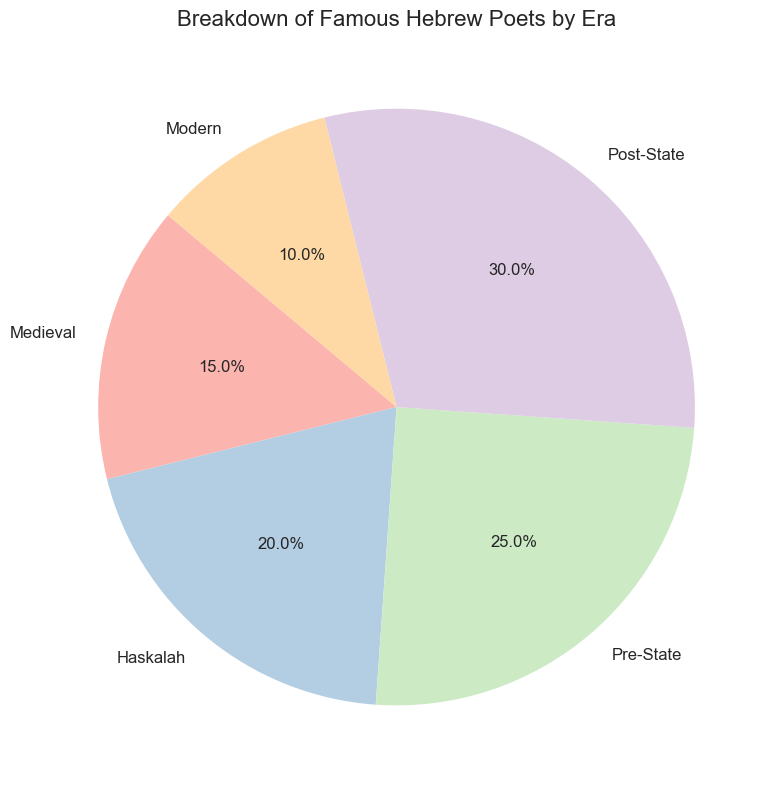What era has the largest representation of famous Hebrew poets according to the chart? Look at the wedges of the pie chart, the era with the largest wedge will have the largest representation. The "Post-State" era has the largest wedge with 30%.
Answer: Post-State What percentage of famous Hebrew poets belongs to the Medieval and Haskalah eras combined? Check the percentages for the Medieval and Haskalah eras, and add them together. Medieval is 15% and Haskalah is 20%, so 15% + 20% = 35%.
Answer: 35% Which era has a smaller representation of famous Hebrew poets, Medieval or Modern? Compare the sizes of the wedges labeled Medieval and Modern. Medieval is 15% and Modern is 10%, thus Modern is smaller.
Answer: Modern By what percentage is the representation of famous Hebrew poets in the Pre-State era greater than the Medieval era? Subtract the percentage of the Medieval era from the Pre-State era. Pre-State is 25% and Medieval is 15%, so 25% - 15% = 10%.
Answer: 10% Rank the eras from highest to lowest percentage of famous Hebrew poets. Order the eras according to their given percentages. Post-State (30%), Pre-State (25%), Haskalah (20%), Medieval (15%), Modern (10%).
Answer: Post-State, Pre-State, Haskalah, Medieval, Modern What fraction of the pie does the Post-State era occupy? Convert the percentage of the Post-State era to a fraction. Post-State is 30%, which is 30/100 or 3/10.
Answer: 3/10 Are the Medieval and Modern eras combined less than the Haskalah era? Add the percentages of the Medieval and Modern eras and compare with the Haskalah era. Medieval is 15% and Modern is 10%, so combined they are 25%, which is the same as Haskalah at 20%.
Answer: No How does the representation of famous Hebrew poets in the Modern era compare to the combined percentage of the Medieval and Pre-State eras? Add the percentages of the Medieval and Pre-State eras and compare with the Modern era. Medieval is 15% and Pre-State is 25%, combined they are 40%, which is significantly more than Modern's 10%.
Answer: The combined percentage is significantly higher 